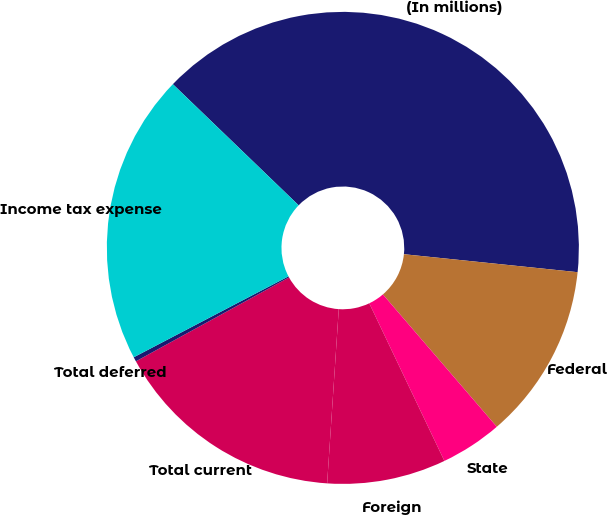Convert chart. <chart><loc_0><loc_0><loc_500><loc_500><pie_chart><fcel>(In millions)<fcel>Federal<fcel>State<fcel>Foreign<fcel>Total current<fcel>Total deferred<fcel>Income tax expense<nl><fcel>39.44%<fcel>12.05%<fcel>4.23%<fcel>8.14%<fcel>15.96%<fcel>0.31%<fcel>19.87%<nl></chart> 